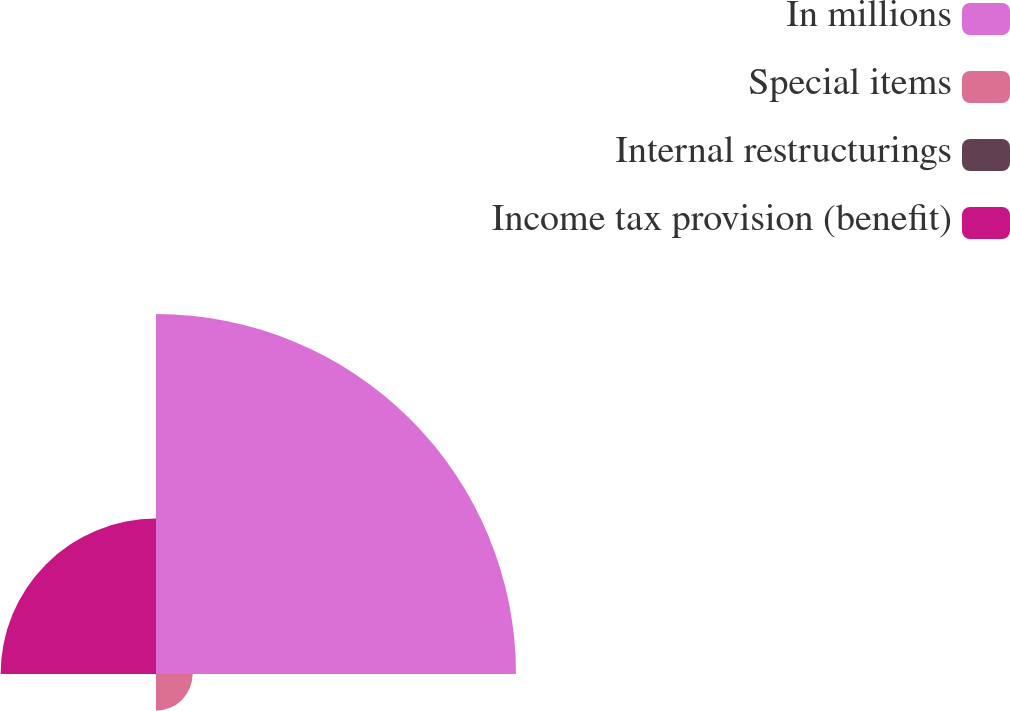Convert chart to OTSL. <chart><loc_0><loc_0><loc_500><loc_500><pie_chart><fcel>In millions<fcel>Special items<fcel>Internal restructurings<fcel>Income tax provision (benefit)<nl><fcel>65.13%<fcel>6.63%<fcel>0.13%<fcel>28.11%<nl></chart> 